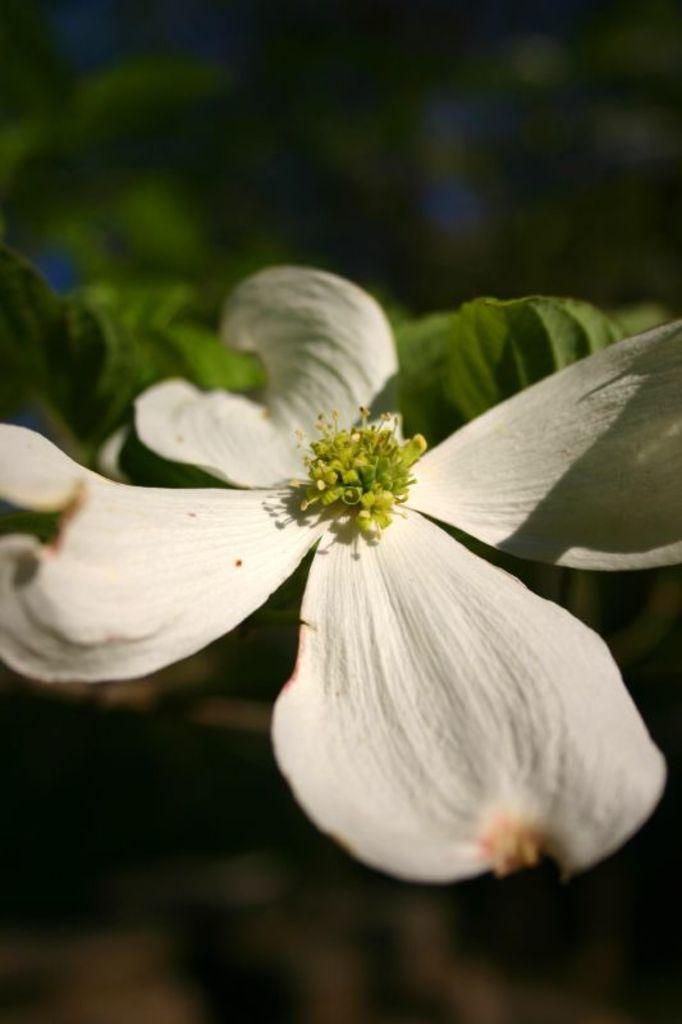What is the main subject of the image? There is a flower in the image. What color is the flower? The flower is white in color. Are there any other parts of the plant visible in the image? Yes, there are leaves associated with the flower. How would you describe the background of the image? The background of the image is blurred. What route do the friends take to reach the flower in the image? There are no friends or route present in the image; it only features a white flower with leaves and a blurred background. 